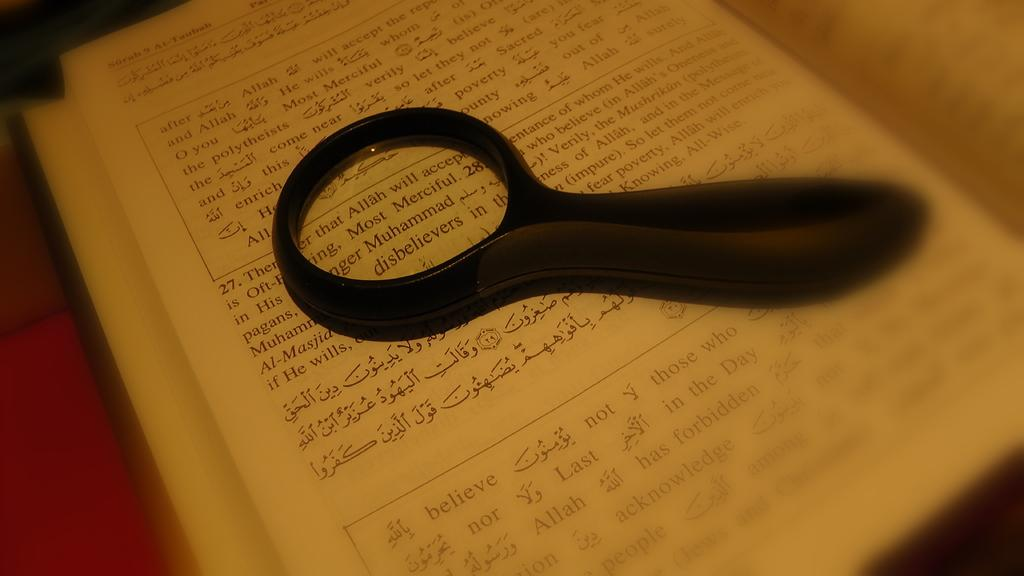<image>
Describe the image concisely. A book page shows text in boxes with the first word in the first box being after. 